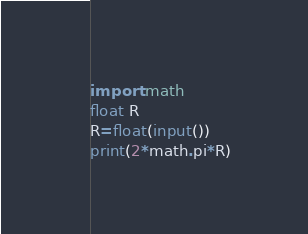Convert code to text. <code><loc_0><loc_0><loc_500><loc_500><_Python_>import math
float R
R=float(input())
print(2*math.pi*R)</code> 